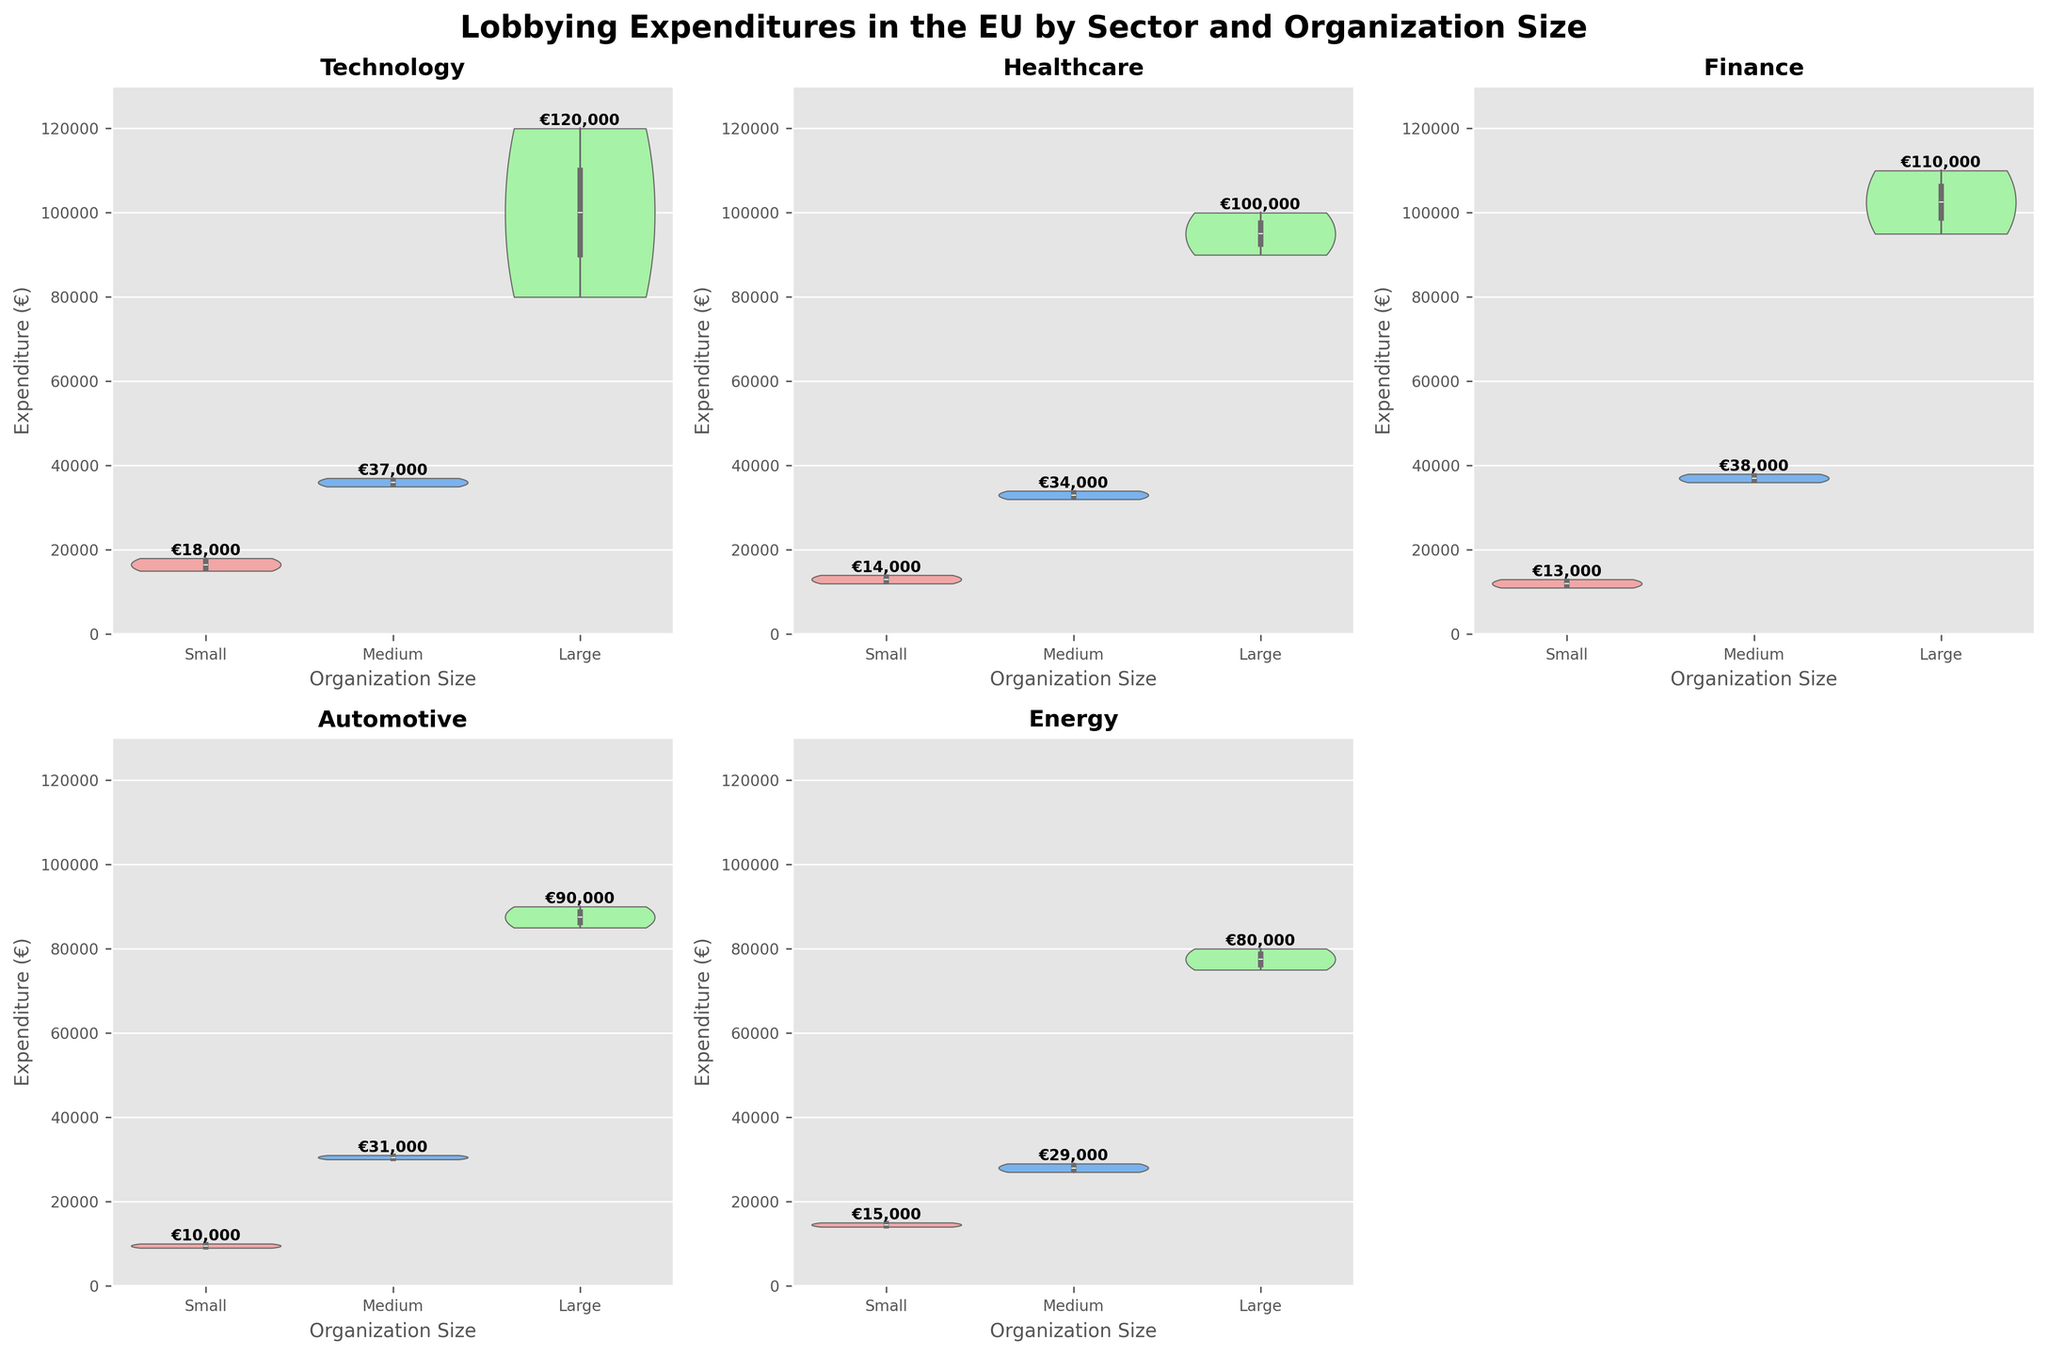What is the title of the figure? The title of the figure is usually displayed at the top of the plot. In this case, it's specified in the code as 'Lobbying Expenditures in the EU by Sector and Organization Size'.
Answer: Lobbying Expenditures in the EU by Sector and Organization Size How many sectors are represented in the figure? Each subplot in the figure corresponds to a different sector. By looking at the different subplots, we can count the number of unique sectors.
Answer: 5 Which organization size has the highest median expenditure in the Technology sector? In a violin plot, the median is typically marked by a white dot or line within the violins. We can locate the median expenditure for each organization size in the Technology sector by examining the corresponding subplot.
Answer: Large What is the range of expenditures for Medium-sized Energy organizations? The range of expenditures can be determined by looking at the bounds of the violin plot for Medium-sized organizations. It stretches from the minimum to the maximum observed values in the dataset.
Answer: €27,000 to €29,000 Which sector has the smallest expenditure range for Large organizations? To determine this, we need to compare the ranges (from minimum to maximum) of expenditures for Large organizations across all sectors. By examining each subplot's corresponding violin, we can identify the sector with the narrowest range.
Answer: Energy How does the median expenditure of Small Finance organizations compare to Small Automotive organizations? By examining the positions of the median marks within the violins for Small organizations in the Finance and Automotive sectors, we can compare their median expenditures.
Answer: Finance is higher What is the approximate maximum expenditure for Large Healthcare organizations? The maximum expenditure appears at the top edge of the violin plot for each organization size within a sector. For Large Healthcare organizations, we find the top of their violin.
Answer: €100,000 Which sector shows the most variability in lobbying expenditures across all organization sizes? Variability within a violin plot can be assessed by looking at the overall width and spread of violins within each sector's subplot. The sector with the widest and most spread out violins across all organization sizes indicates the highest variability.
Answer: Technology Do Medium-sized organizations generally have higher expenditures than Small organizations within the Energy sector? By comparing the position of the violins for Medium and Small organizations within the Energy sector subplot, we can determine if the median or overall range of expenditures is generally higher for Medium than for Small.
Answer: Yes 